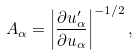<formula> <loc_0><loc_0><loc_500><loc_500>A _ { \alpha } = \left | \frac { \partial u _ { \alpha } ^ { \prime } } { \partial u _ { \alpha } } \right | ^ { - 1 / 2 } ,</formula> 